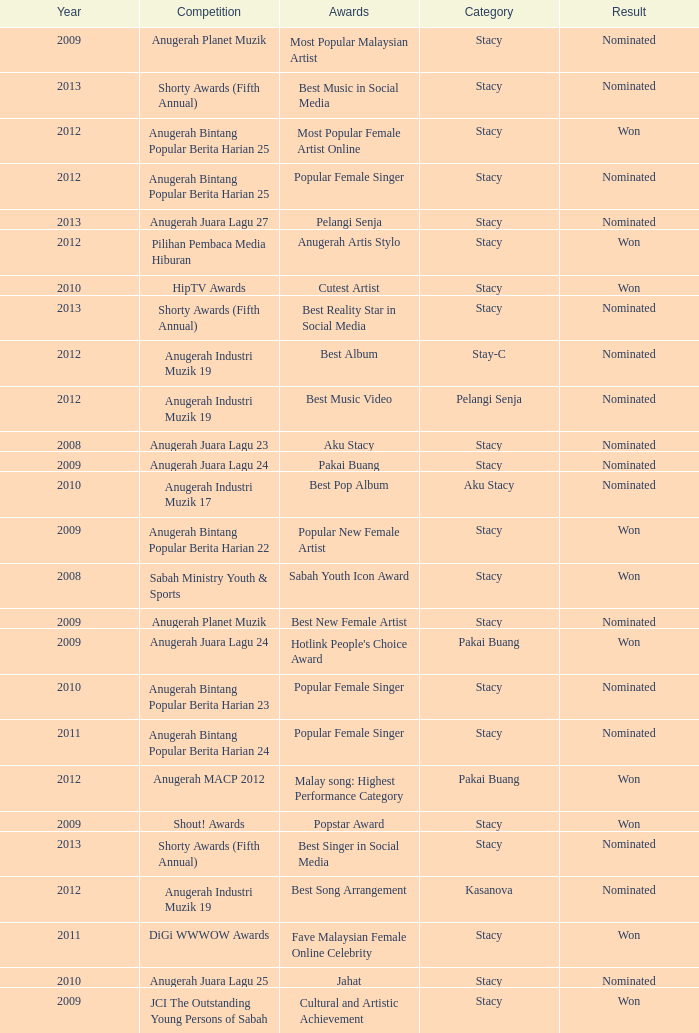What year has Stacy as the category and award of Best Reality Star in Social Media? 2013.0. 